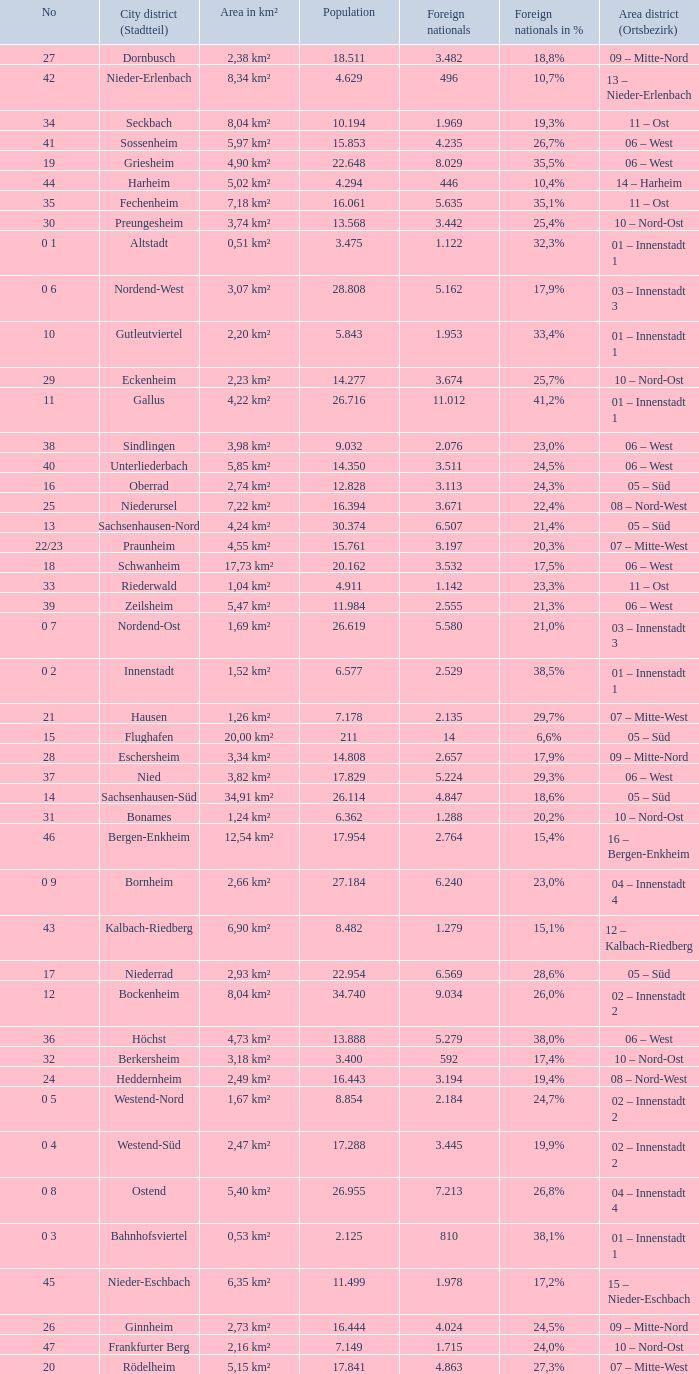How many foreigners in percentage terms had a population of 4.911? 1.0. 